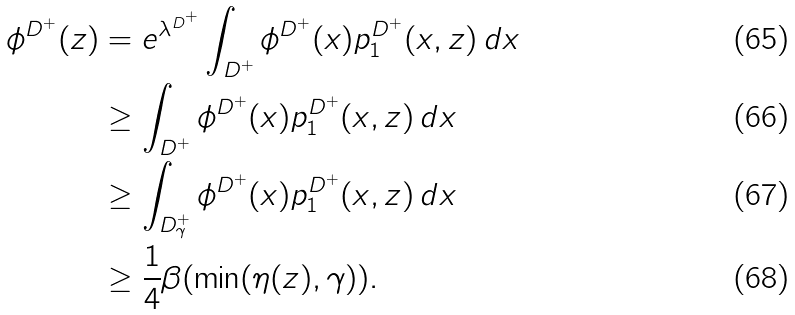<formula> <loc_0><loc_0><loc_500><loc_500>\phi ^ { D ^ { + } } ( z ) & = e ^ { \lambda ^ { D ^ { + } } } \int _ { D ^ { + } } \phi ^ { D ^ { + } } ( x ) p _ { 1 } ^ { D ^ { + } } ( x , z ) \, d x \\ & \geq \int _ { D ^ { + } } \phi ^ { D ^ { + } } ( x ) p _ { 1 } ^ { D ^ { + } } ( x , z ) \, d x \\ & \geq \int _ { D ^ { + } _ { \gamma } } \phi ^ { D ^ { + } } ( x ) p _ { 1 } ^ { D ^ { + } } ( x , z ) \, d x \\ & \geq \frac { 1 } { 4 } \beta ( \min ( \eta ( z ) , \gamma ) ) .</formula> 